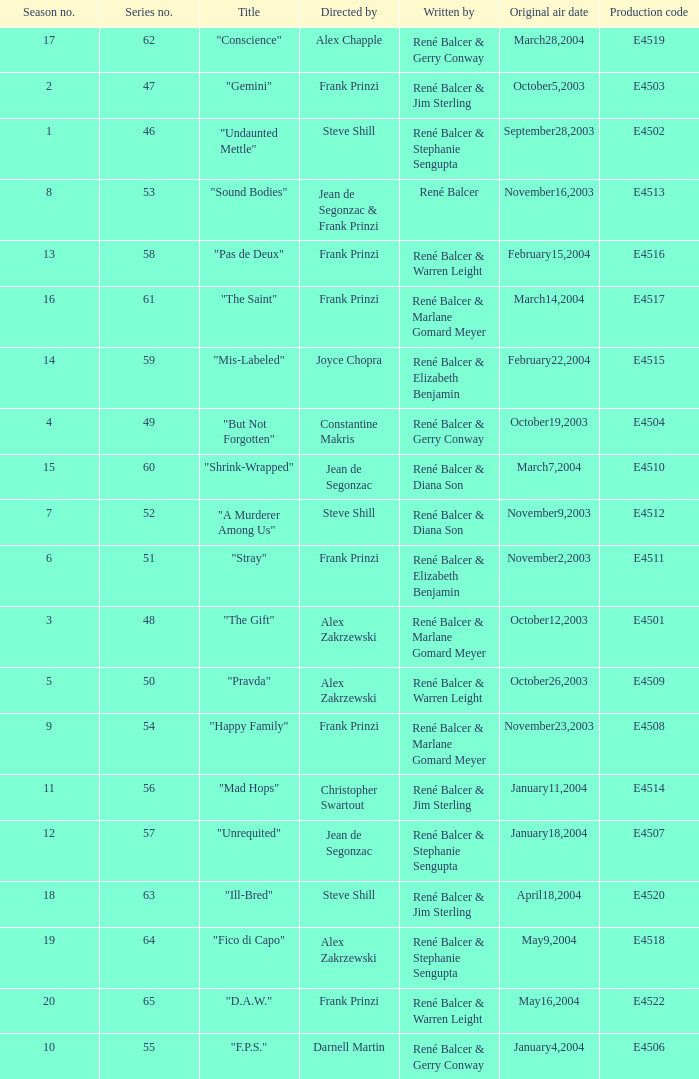Who wrote the episode with e4515 as the production code? René Balcer & Elizabeth Benjamin. 